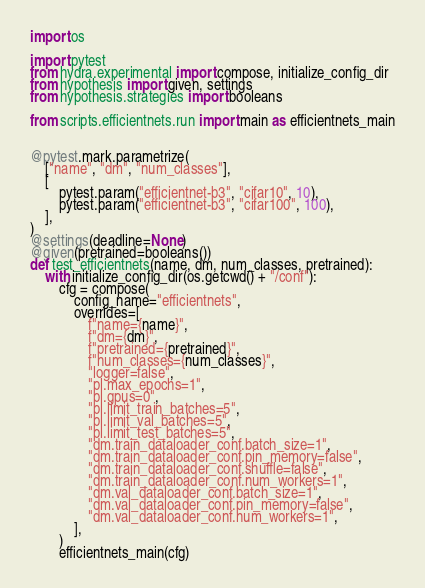Convert code to text. <code><loc_0><loc_0><loc_500><loc_500><_Python_>import os

import pytest
from hydra.experimental import compose, initialize_config_dir
from hypothesis import given, settings
from hypothesis.strategies import booleans

from scripts.efficientnets.run import main as efficientnets_main


@pytest.mark.parametrize(
    ["name", "dm", "num_classes"],
    [
        pytest.param("efficientnet-b3", "cifar10", 10),
        pytest.param("efficientnet-b3", "cifar100", 100),
    ],
)
@settings(deadline=None)
@given(pretrained=booleans())
def test_efficientnets(name, dm, num_classes, pretrained):
    with initialize_config_dir(os.getcwd() + "/conf"):
        cfg = compose(
            config_name="efficientnets",
            overrides=[
                f"name={name}",
                f"dm={dm}",
                f"pretrained={pretrained}",
                f"num_classes={num_classes}",
                "logger=false",
                "pl.max_epochs=1",
                "pl.gpus=0",
                "pl.limit_train_batches=5",
                "pl.limit_val_batches=5",
                "pl.limit_test_batches=5",
                "dm.train_dataloader_conf.batch_size=1",
                "dm.train_dataloader_conf.pin_memory=false",
                "dm.train_dataloader_conf.shuffle=false",
                "dm.train_dataloader_conf.num_workers=1",
                "dm.val_dataloader_conf.batch_size=1",
                "dm.val_dataloader_conf.pin_memory=false",
                "dm.val_dataloader_conf.num_workers=1",
            ],
        )
        efficientnets_main(cfg)
</code> 